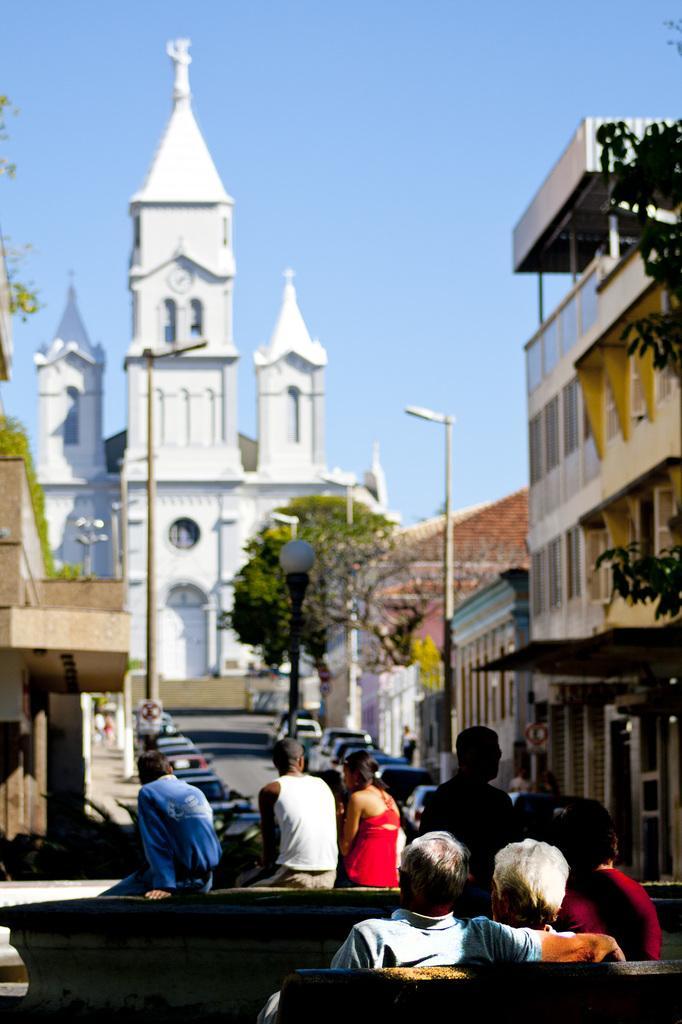Please provide a concise description of this image. In this picture, we can see buildings with windows, poles, lights, a few vehicles, and a few people in vehicle, we can see trees and the sky. 